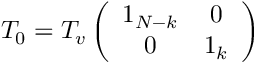Convert formula to latex. <formula><loc_0><loc_0><loc_500><loc_500>T _ { 0 } = T _ { v } \left ( \begin{array} { c c } { { 1 _ { N - k } } } & { 0 } \\ { 0 } & { { 1 _ { k } } } \end{array} \right )</formula> 